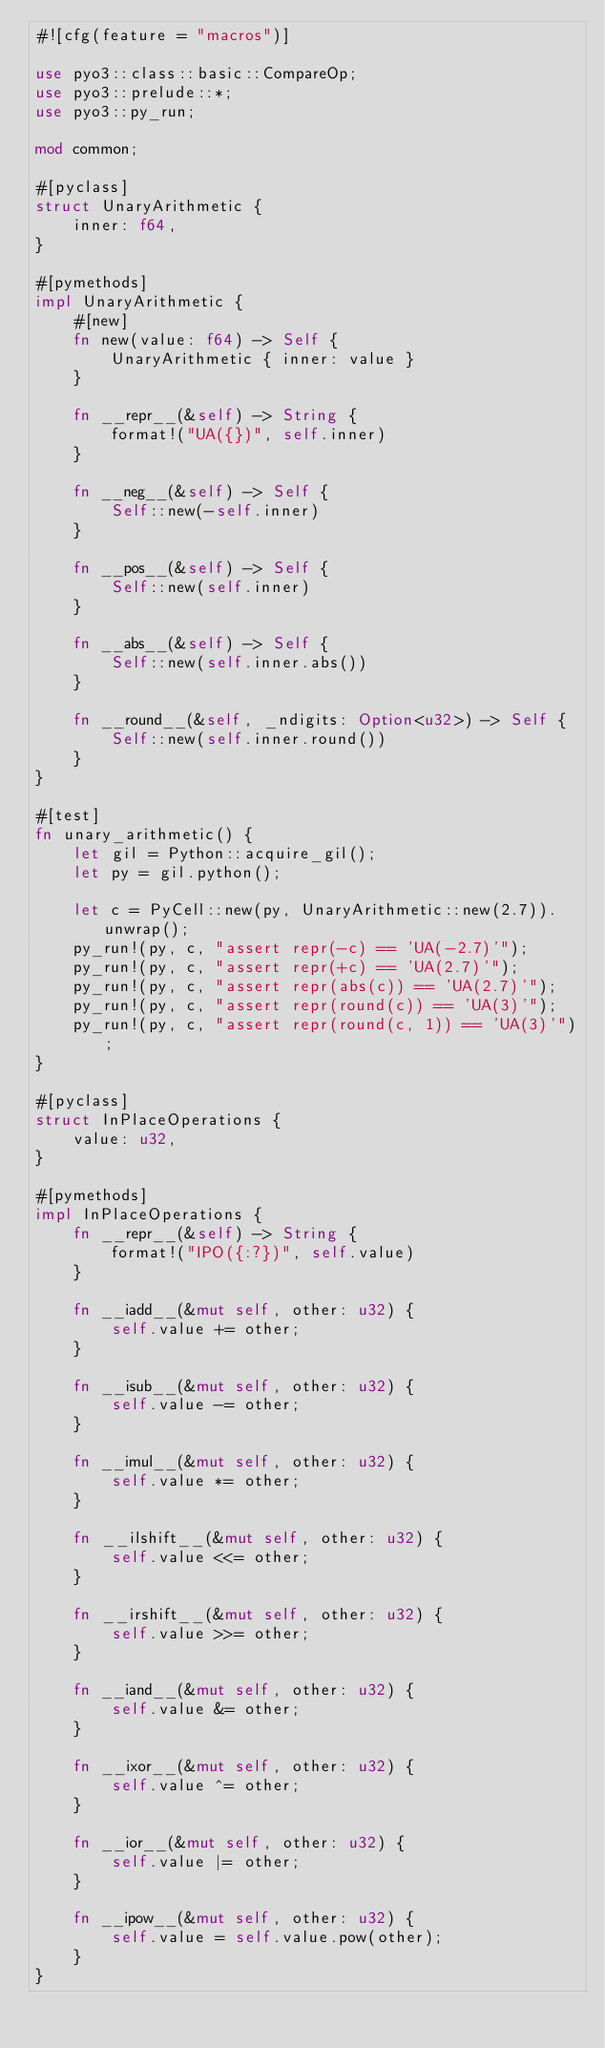<code> <loc_0><loc_0><loc_500><loc_500><_Rust_>#![cfg(feature = "macros")]

use pyo3::class::basic::CompareOp;
use pyo3::prelude::*;
use pyo3::py_run;

mod common;

#[pyclass]
struct UnaryArithmetic {
    inner: f64,
}

#[pymethods]
impl UnaryArithmetic {
    #[new]
    fn new(value: f64) -> Self {
        UnaryArithmetic { inner: value }
    }

    fn __repr__(&self) -> String {
        format!("UA({})", self.inner)
    }

    fn __neg__(&self) -> Self {
        Self::new(-self.inner)
    }

    fn __pos__(&self) -> Self {
        Self::new(self.inner)
    }

    fn __abs__(&self) -> Self {
        Self::new(self.inner.abs())
    }

    fn __round__(&self, _ndigits: Option<u32>) -> Self {
        Self::new(self.inner.round())
    }
}

#[test]
fn unary_arithmetic() {
    let gil = Python::acquire_gil();
    let py = gil.python();

    let c = PyCell::new(py, UnaryArithmetic::new(2.7)).unwrap();
    py_run!(py, c, "assert repr(-c) == 'UA(-2.7)'");
    py_run!(py, c, "assert repr(+c) == 'UA(2.7)'");
    py_run!(py, c, "assert repr(abs(c)) == 'UA(2.7)'");
    py_run!(py, c, "assert repr(round(c)) == 'UA(3)'");
    py_run!(py, c, "assert repr(round(c, 1)) == 'UA(3)'");
}

#[pyclass]
struct InPlaceOperations {
    value: u32,
}

#[pymethods]
impl InPlaceOperations {
    fn __repr__(&self) -> String {
        format!("IPO({:?})", self.value)
    }

    fn __iadd__(&mut self, other: u32) {
        self.value += other;
    }

    fn __isub__(&mut self, other: u32) {
        self.value -= other;
    }

    fn __imul__(&mut self, other: u32) {
        self.value *= other;
    }

    fn __ilshift__(&mut self, other: u32) {
        self.value <<= other;
    }

    fn __irshift__(&mut self, other: u32) {
        self.value >>= other;
    }

    fn __iand__(&mut self, other: u32) {
        self.value &= other;
    }

    fn __ixor__(&mut self, other: u32) {
        self.value ^= other;
    }

    fn __ior__(&mut self, other: u32) {
        self.value |= other;
    }

    fn __ipow__(&mut self, other: u32) {
        self.value = self.value.pow(other);
    }
}
</code> 